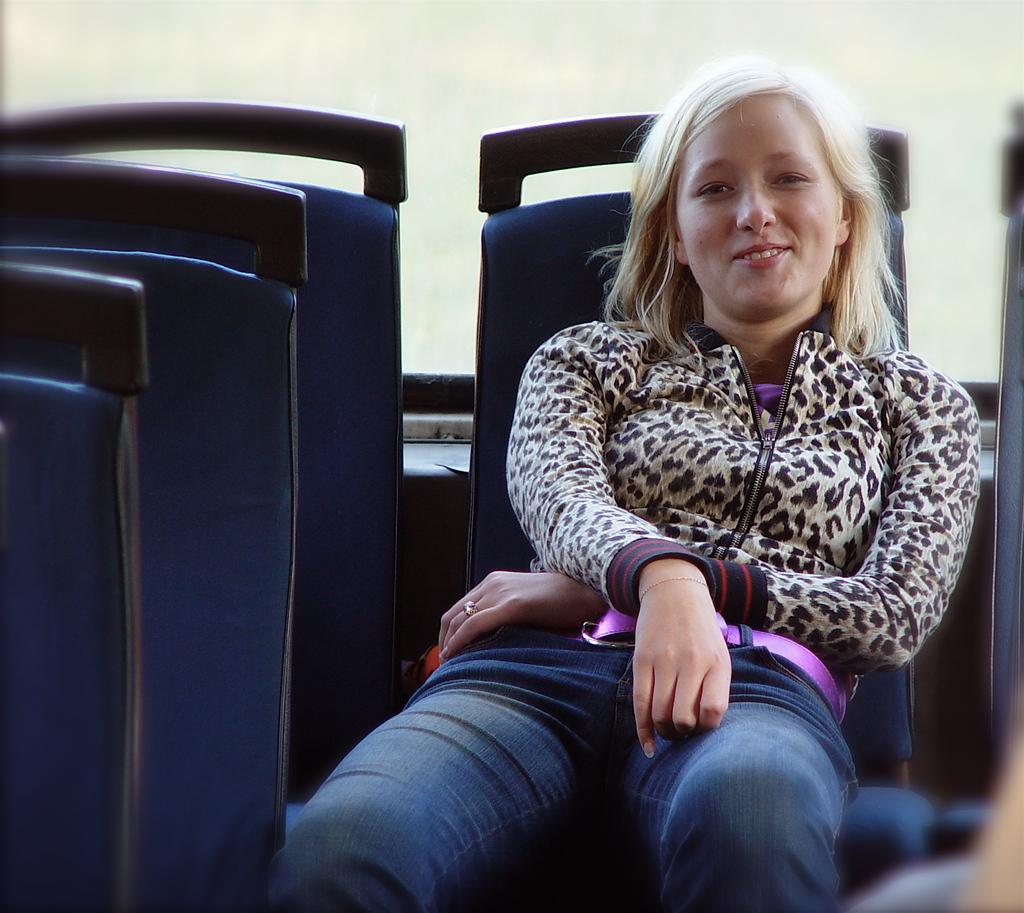Could you give a brief overview of what you see in this image? a girl is sitting on a seat is wearing a tiger print jacket and a jeans 